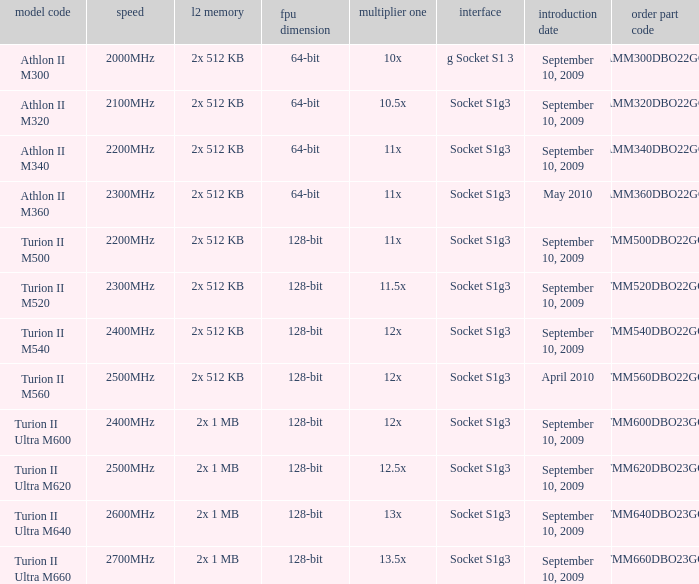What is the L2 cache with a release date on September 10, 2009, a 128-bit FPU width, and a 12x multi 1? 2x 512 KB, 2x 1 MB. 